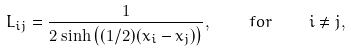Convert formula to latex. <formula><loc_0><loc_0><loc_500><loc_500>L _ { i j } = \frac { 1 } { 2 \sinh \left ( ( 1 / 2 ) ( x _ { i } - x _ { j } ) \right ) } , \quad f o r \quad i \neq j ,</formula> 